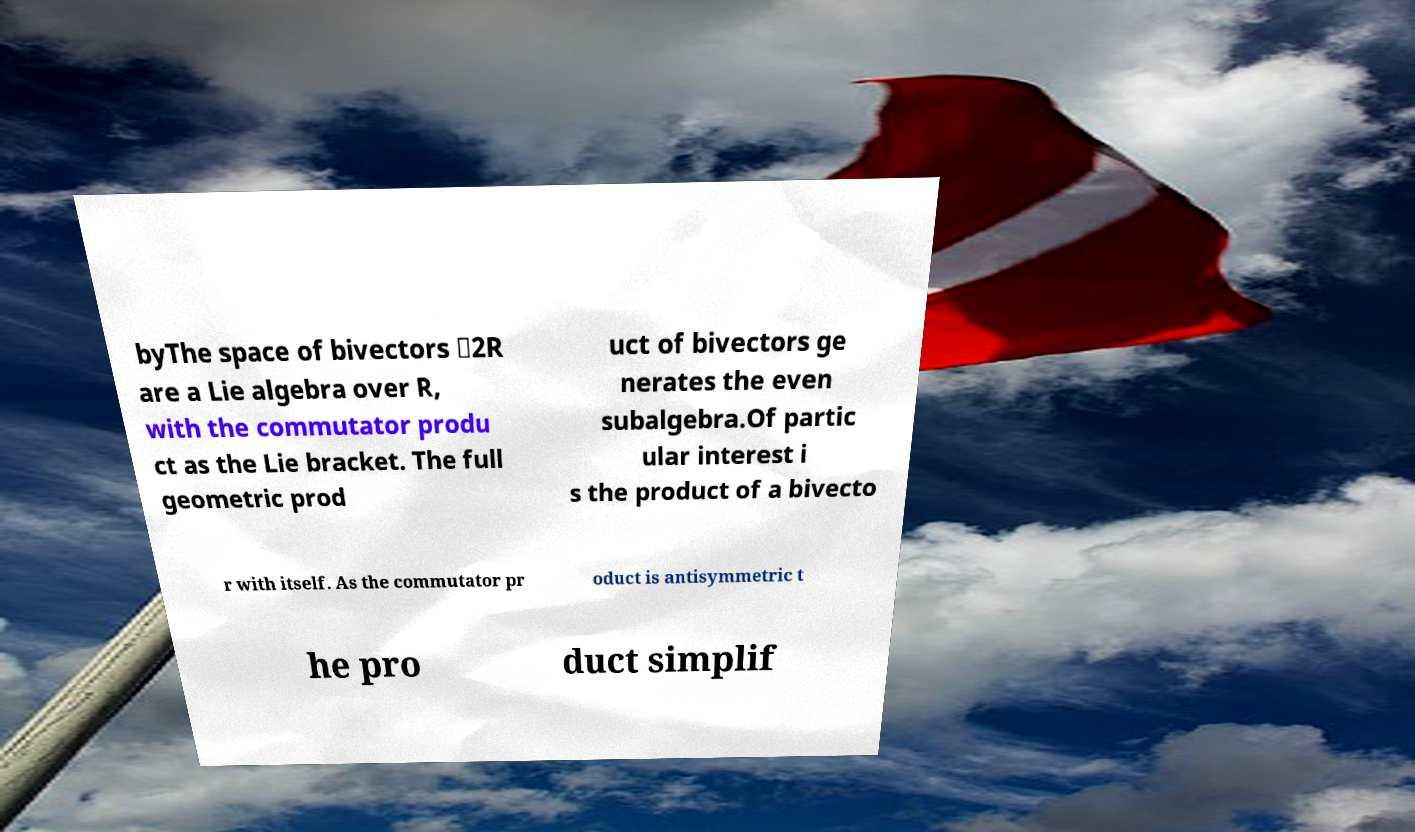Please identify and transcribe the text found in this image. byThe space of bivectors ⋀2R are a Lie algebra over R, with the commutator produ ct as the Lie bracket. The full geometric prod uct of bivectors ge nerates the even subalgebra.Of partic ular interest i s the product of a bivecto r with itself. As the commutator pr oduct is antisymmetric t he pro duct simplif 